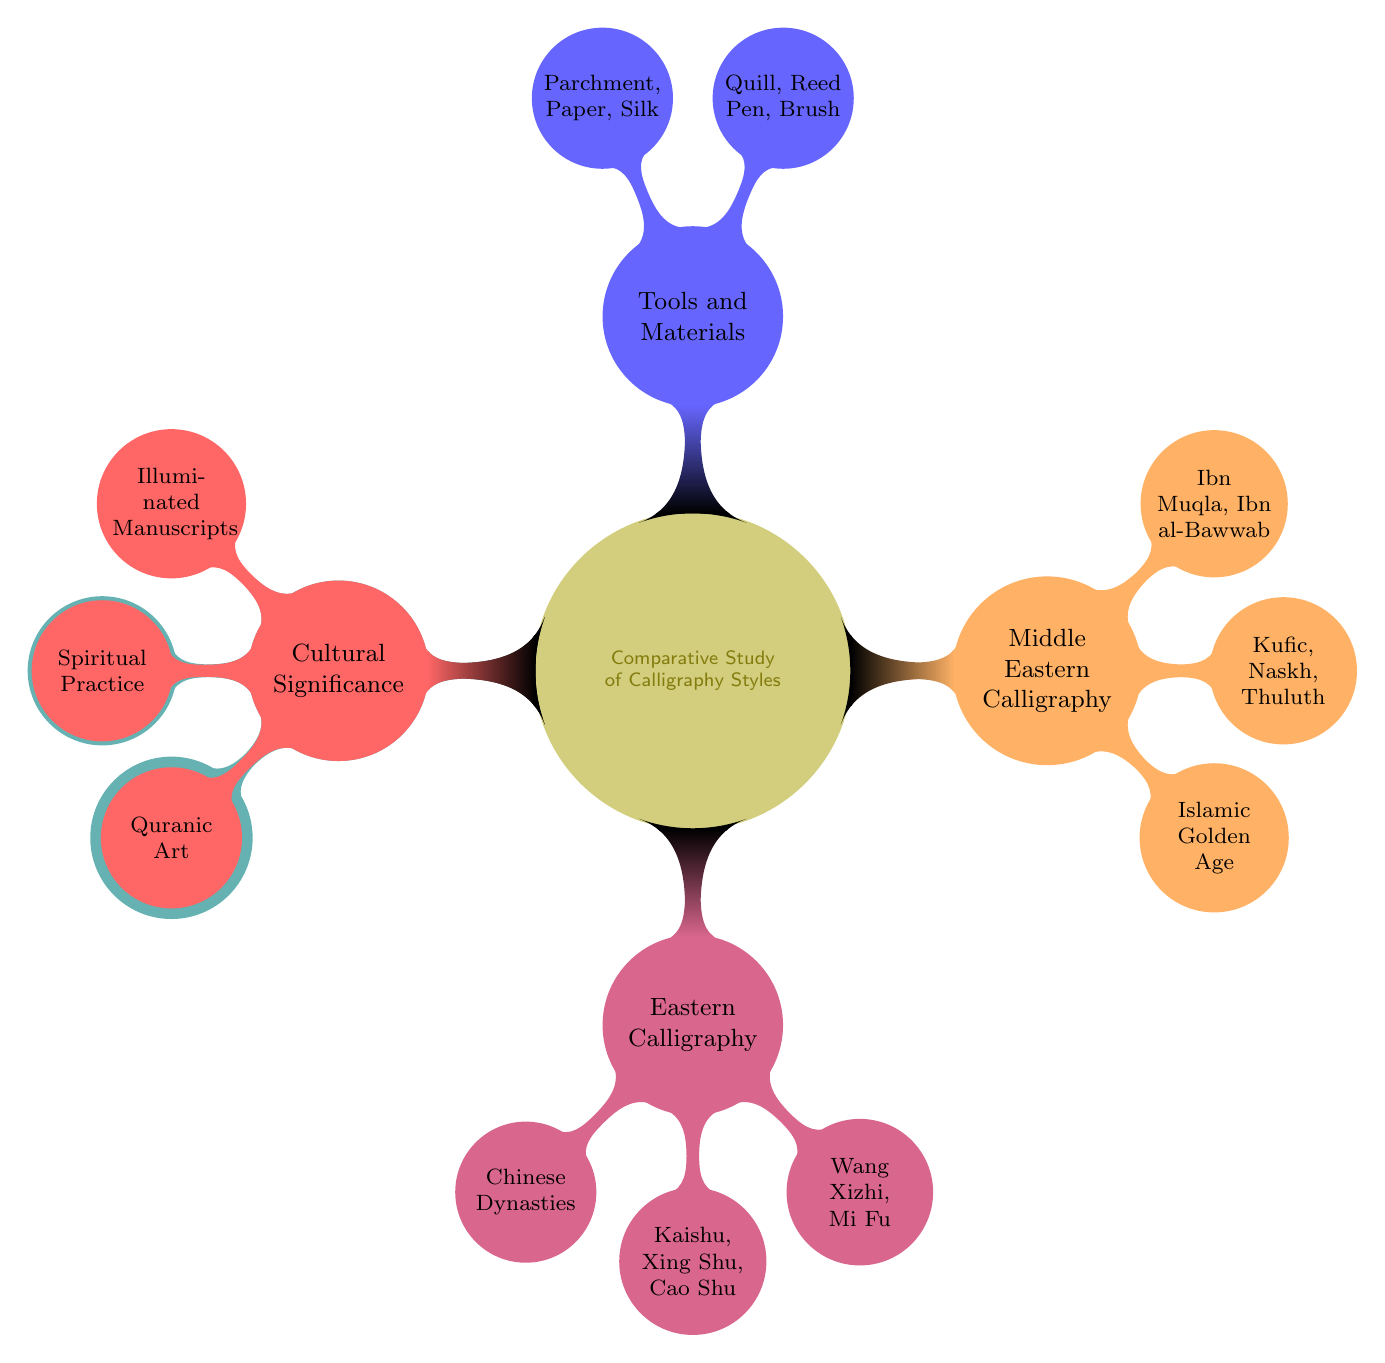What are the major styles of Western Calligraphy? The diagram lists the major styles under the "Western Calligraphy" node, which includes Gothic, Italic, and Copperplate.
Answer: Gothic, Italic, Copperplate What is the historical context of Middle Eastern Calligraphy? The diagram specifies that the historical context for Middle Eastern Calligraphy is the Islamic Golden Age, found under the corresponding node.
Answer: Islamic Golden Age How many famous practitioners are listed for Eastern Calligraphy? Looking at the node for Eastern Calligraphy, there are two famous practitioners mentioned: Wang Xizhi and Mi Fu, so the count is two.
Answer: 2 What writing instruments are included under Tools and Materials? The Tools and Materials node details writing instruments which include Quill, Reed Pen, and Brush.
Answer: Quill, Reed Pen, Brush What cultural significance is associated with Eastern Calligraphy? The diagram indicates that Eastern Calligraphy is associated with Spiritual Practice, as stated in its cultural significance node.
Answer: Spiritual Practice Which calligraphy styles are associated with Eastern Calligraphy? The Eastern Calligraphy node lists its styles as Kaishu, Xing Shu, and Cao Shu.
Answer: Kaishu, Xing Shu, Cao Shu What do the tools and materials segment contribute to the practice of calligraphy? The tools and materials segment enhances understanding by showing that instruments and surfaces like Quill, Parchment, and Silk are essential to different calligraphy styles.
Answer: Writing Instruments and Surfaces Which cultural significance relates to Western Calligraphy? The cultural significance for Western Calligraphy is identified as Illuminated Manuscripts, linking its meaning to a specific artistic practice.
Answer: Illuminated Manuscripts What is the relationship between Western Calligraphy and its famous practitioners? The relationship shows that the famous practitioners Edward Johnston and Donald Jackson are exemplars of the Western Calligraphy style, indicating important figures in its history.
Answer: Important figures in its history 